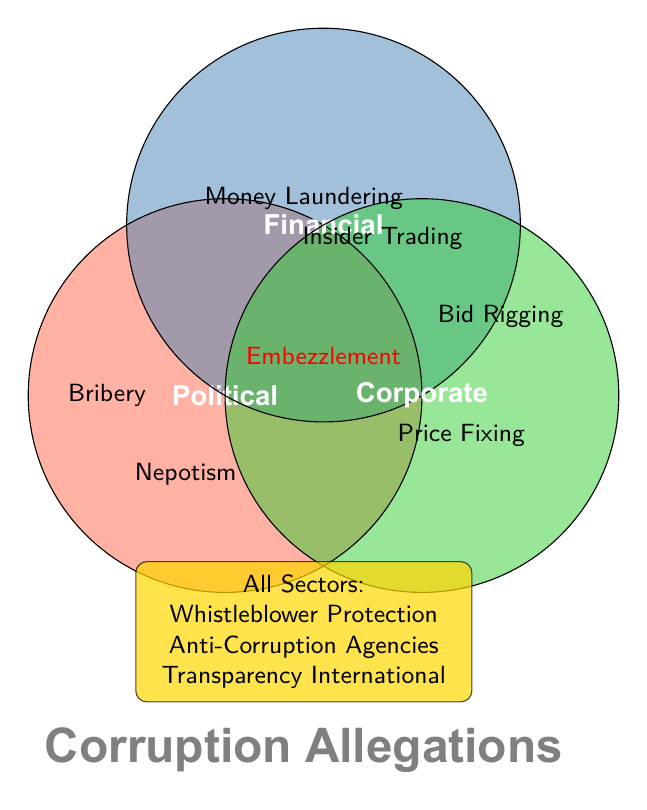Which categories include Embezzlement? Embezzlement is located at the intersection of the Political and Financial circles. Therefore, it belongs to both Political and Financial Corruption categories.
Answer: Political and Financial Corruption Which item is found in all sectors of corruption? The items in the category 'All' are inside a separate box outside the Venn Diagram and labeled as applicable to all sectors. These items are Whistleblower Protection, Anti-Corruption Agencies, and Transparency International.
Answer: Whistleblower Protection, Anti-Corruption Agencies, Transparency International Which item is common to both Political and Corporate Corruption categories? By observing the overlapping areas of Political and Corporate Corruption, Bribery is the item that lies in the intersection of these two circles.
Answer: Bribery How many distinct items are listed under Corporate Corruption? Corporate Corruption includes Bid Rigging, Price Fixing, and Bribery. Counting these items gives three distinct items.
Answer: 3 What overlaps can be observed for the Financial Corruption category? Embezzlement belongs to both Financial and Political categories, while no items are found at the intersection of Financial and Corporate directly. Financial-specific items are Money Laundering and Insider Trading.
Answer: Embezzlement (with Political), and specific items are Money Laundering, Insider Trading List the items unique to Political Corruption. To find the unique items, exclude the overlapping items. Bribery overlaps with Corporate, and Embezzlement overlaps with Financial. The remaining items unique to Political Corruption are Nepotism.
Answer: Nepotism 